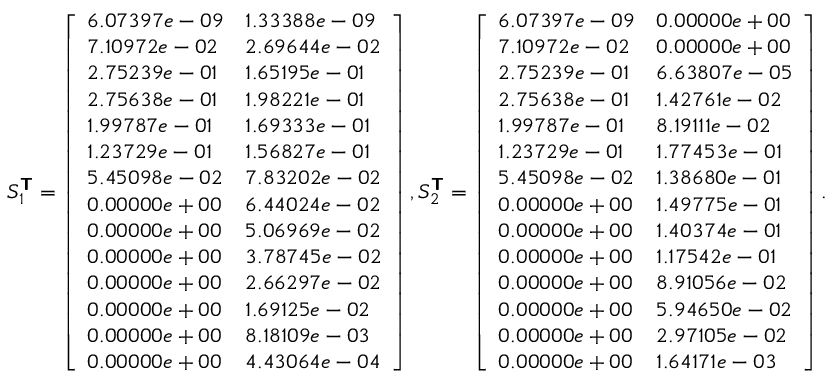<formula> <loc_0><loc_0><loc_500><loc_500>S _ { 1 } ^ { T } = \left [ \begin{array} { l l } { 6 . 0 7 3 9 7 e - 0 9 } & { 1 . 3 3 3 8 8 e - 0 9 } \\ { 7 . 1 0 9 7 2 e - 0 2 } & { 2 . 6 9 6 4 4 e - 0 2 } \\ { 2 . 7 5 2 3 9 e - 0 1 } & { 1 . 6 5 1 9 5 e - 0 1 } \\ { 2 . 7 5 6 3 8 e - 0 1 } & { 1 . 9 8 2 2 1 e - 0 1 } \\ { 1 . 9 9 7 8 7 e - 0 1 } & { 1 . 6 9 3 3 3 e - 0 1 } \\ { 1 . 2 3 7 2 9 e - 0 1 } & { 1 . 5 6 8 2 7 e - 0 1 } \\ { 5 . 4 5 0 9 8 e - 0 2 } & { 7 . 8 3 2 0 2 e - 0 2 } \\ { 0 . 0 0 0 0 0 e + 0 0 } & { 6 . 4 4 0 2 4 e - 0 2 } \\ { 0 . 0 0 0 0 0 e + 0 0 } & { 5 . 0 6 9 6 9 e - 0 2 } \\ { 0 . 0 0 0 0 0 e + 0 0 } & { 3 . 7 8 7 4 5 e - 0 2 } \\ { 0 . 0 0 0 0 0 e + 0 0 } & { 2 . 6 6 2 9 7 e - 0 2 } \\ { 0 . 0 0 0 0 0 e + 0 0 } & { 1 . 6 9 1 2 5 e - 0 2 } \\ { 0 . 0 0 0 0 0 e + 0 0 } & { 8 . 1 8 1 0 9 e - 0 3 } \\ { 0 . 0 0 0 0 0 e + 0 0 } & { 4 . 4 3 0 6 4 e - 0 4 } \end{array} \right ] , S _ { 2 } ^ { T } = \left [ \begin{array} { l l } { 6 . 0 7 3 9 7 e - 0 9 } & { 0 . 0 0 0 0 0 e + 0 0 } \\ { 7 . 1 0 9 7 2 e - 0 2 } & { 0 . 0 0 0 0 0 e + 0 0 } \\ { 2 . 7 5 2 3 9 e - 0 1 } & { 6 . 6 3 8 0 7 e - 0 5 } \\ { 2 . 7 5 6 3 8 e - 0 1 } & { 1 . 4 2 7 6 1 e - 0 2 } \\ { 1 . 9 9 7 8 7 e - 0 1 } & { 8 . 1 9 1 1 1 e - 0 2 } \\ { 1 . 2 3 7 2 9 e - 0 1 } & { 1 . 7 7 4 5 3 e - 0 1 } \\ { 5 . 4 5 0 9 8 e - 0 2 } & { 1 . 3 8 6 8 0 e - 0 1 } \\ { 0 . 0 0 0 0 0 e + 0 0 } & { 1 . 4 9 7 7 5 e - 0 1 } \\ { 0 . 0 0 0 0 0 e + 0 0 } & { 1 . 4 0 3 7 4 e - 0 1 } \\ { 0 . 0 0 0 0 0 e + 0 0 } & { 1 . 1 7 5 4 2 e - 0 1 } \\ { 0 . 0 0 0 0 0 e + 0 0 } & { 8 . 9 1 0 5 6 e - 0 2 } \\ { 0 . 0 0 0 0 0 e + 0 0 } & { 5 . 9 4 6 5 0 e - 0 2 } \\ { 0 . 0 0 0 0 0 e + 0 0 } & { 2 . 9 7 1 0 5 e - 0 2 } \\ { 0 . 0 0 0 0 0 e + 0 0 } & { 1 . 6 4 1 7 1 e - 0 3 } \end{array} \right ] .</formula> 